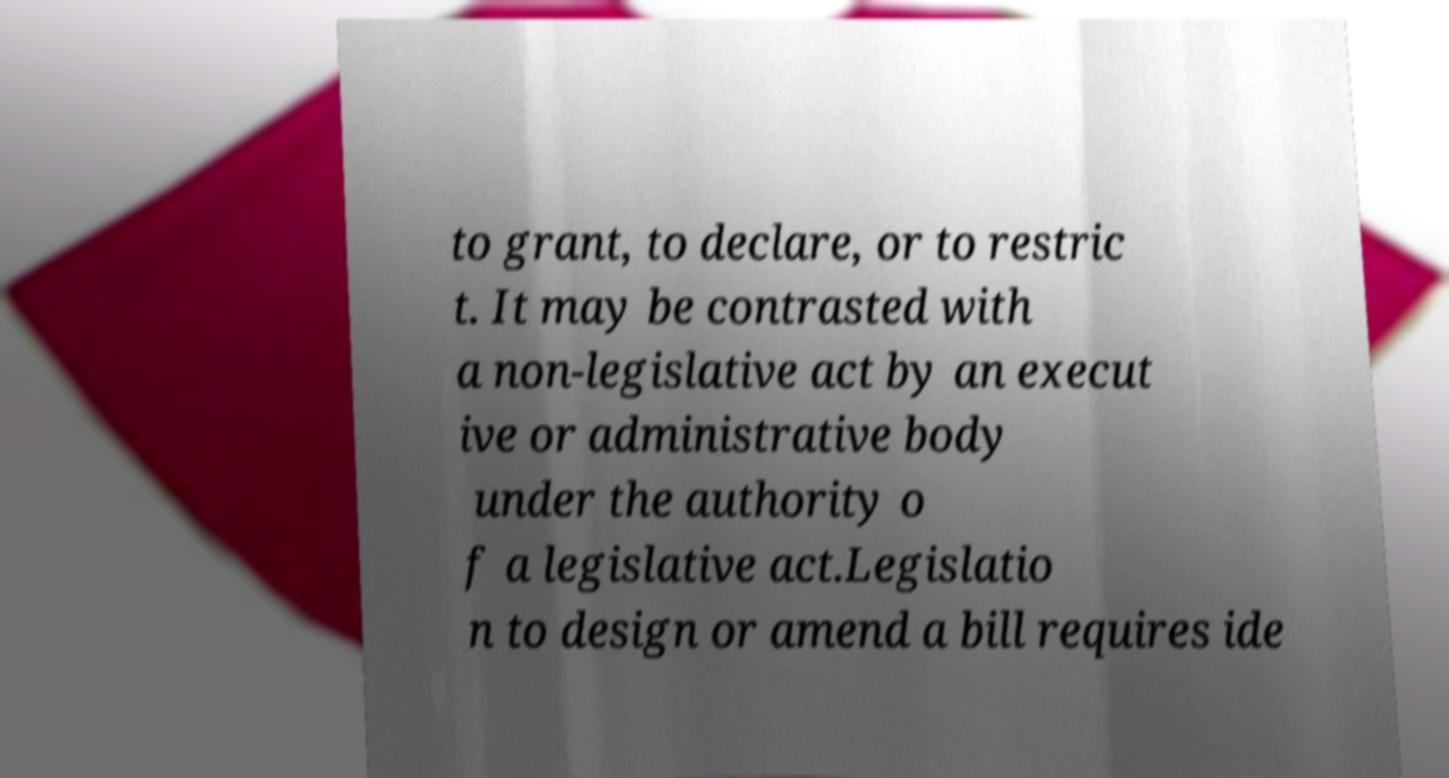Please identify and transcribe the text found in this image. to grant, to declare, or to restric t. It may be contrasted with a non-legislative act by an execut ive or administrative body under the authority o f a legislative act.Legislatio n to design or amend a bill requires ide 